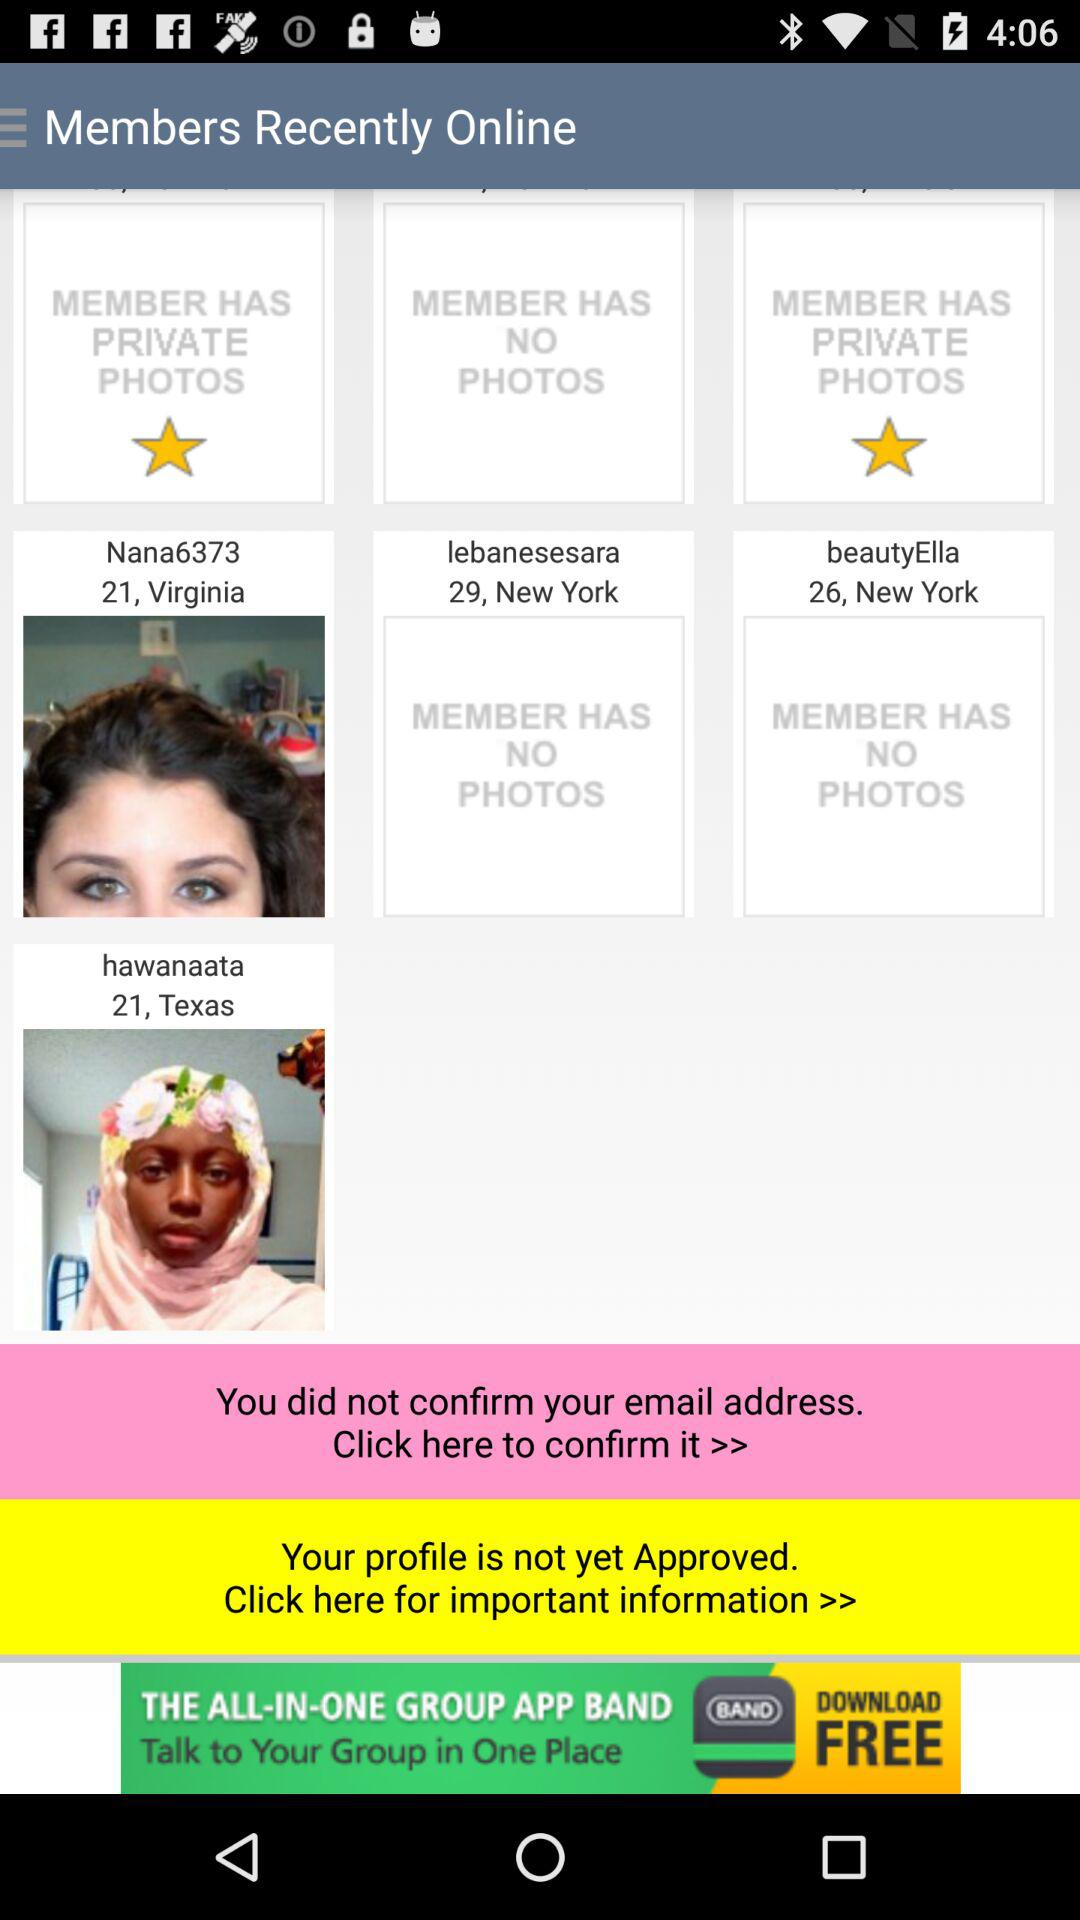What is the age of lebanesesara? The age of Lebanesesara is 29. 